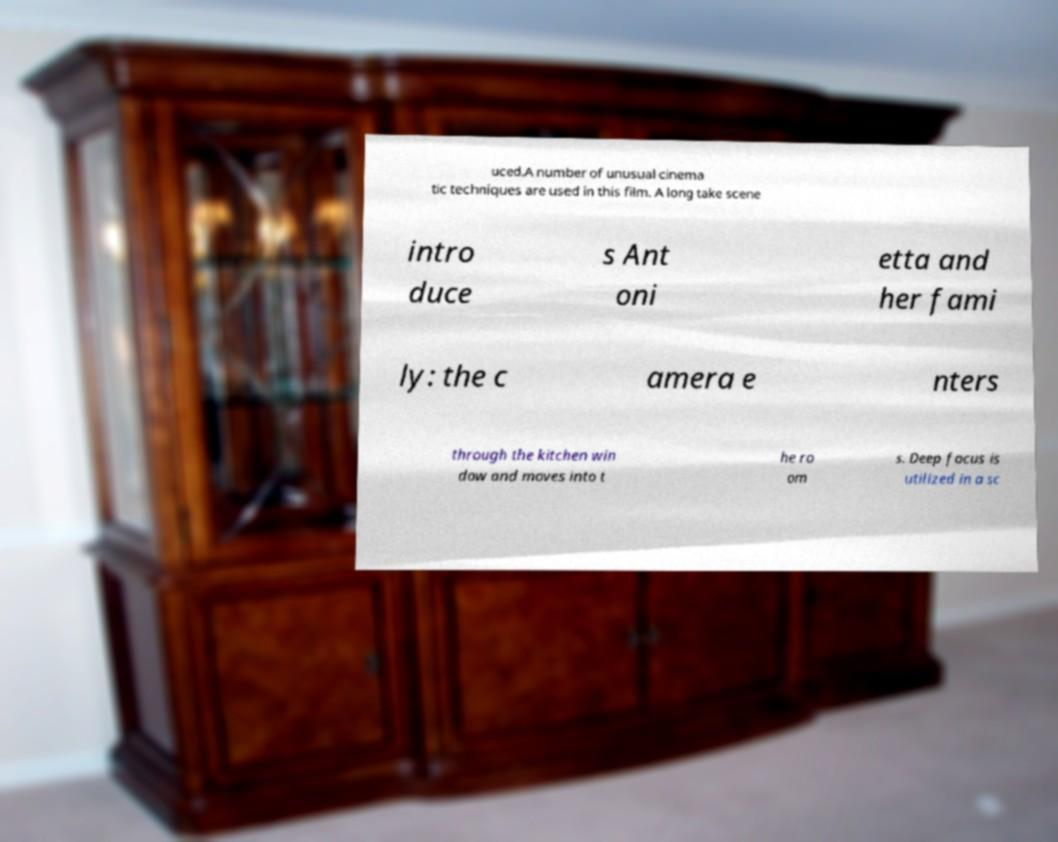There's text embedded in this image that I need extracted. Can you transcribe it verbatim? uced.A number of unusual cinema tic techniques are used in this film. A long take scene intro duce s Ant oni etta and her fami ly: the c amera e nters through the kitchen win dow and moves into t he ro om s. Deep focus is utilized in a sc 